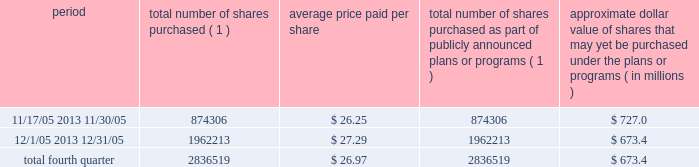Discussion and analysis of financial condition and results of operations 2014liquidity and capital resources 2014 factors affecting sources of liquidity . 201d recent sales of unregistered securities during the year ended december 31 , 2005 , we issued an aggregate of 4670335 shares of our class a common stock upon conversion of $ 57.1 million principal amount of our 3.25% ( 3.25 % ) notes .
Pursuant to the terms of the indenture , the holders of the 3.25% ( 3.25 % ) notes received 81.808 shares of class a common stock for every $ 1000 principal amount of notes converted .
The shares were issued to the noteholders in reliance on the exemption from registration set forth in section 3 ( a ) ( 9 ) of the securities act of 1933 , as amended .
No underwriters were engaged in connection with such issuances .
In connection with the conversion , we paid such holders an aggregate of $ 4.9 million , calculated based on the accrued and unpaid interest on the notes and the discounted value of the future interest payments on the notes .
Subsequent to december 31 , 2005 , we issued shares of class a common stock upon conversions of additional 3.25% ( 3.25 % ) notes , as set forth in item 9b of this annual report under the caption 201cother information . 201d during the year ended december 31 , 2005 , we issued an aggregate of 398412 shares of our class a common stock upon exercises of 55729 warrants assumed in our merger with spectrasite , inc .
In august 2005 , in connection with our merger with spectrasite , inc. , we assumed approximately 1.0 million warrants to purchase shares of spectrasite , inc .
Common stock .
Upon completion of the merger , each warrant to purchase shares of spectrasite , inc .
Common stock automatically converted into a warrant to purchase 7.15 shares of class a common stock at an exercise price of $ 32 per warrant .
Net proceeds from these warrant exercises were approximately $ 1.8 million .
The shares of class a common stock issued to the warrantholders upon exercise of the warrants were issued in reliance on the exemption from registration set forth in section 3 ( a ) ( 9 ) of the securities act of 1933 , as amended .
No underwriters were engaged in connection with such issuances .
Subsequent to december 31 , 2005 , we issued shares of class a common stock upon exercises of additional warrants , as set forth in item 9b of this annual report under the caption 201cother information . 201d issuer purchases of equity securities in november 2005 , we announced that our board of directors had approved a stock repurchase program pursuant to which we intend to repurchase up to $ 750.0 million of our class a common stock through december 2006 .
During the fourth quarter of 2005 , we repurchased 2836519 shares of our class a common stock for an aggregate of $ 76.6 million pursuant to our stock repurchase program , as follows : period total number of shares purchased ( 1 ) average price paid per share total number of shares purchased as part of publicly announced plans or programs ( 1 ) approximate dollar value of shares that may yet be purchased under the plans or programs ( in millions ) .
( 1 ) all issuer repurchases were made pursuant to the stock repurchase program publicly announced in november 2005 .
Pursuant to the program , we intend to repurchase up to $ 750.0 million of our class a common stock during the period november 2005 through december 2006 .
Under the program , our management is authorized to purchase shares from time to time in open market purchases or privately negotiated transactions at prevailing prices as permitted by securities laws and other legal requirements , and subject to market conditions and other factors .
To facilitate repurchases , we entered into a trading plan under rule 10b5-1 of the securities exchange act of 1934 , which allows us to repurchase shares during periods when we otherwise might be prevented from doing so under insider trading laws or because of self- imposed trading blackout periods .
The program may be discontinued at any time .
Since december 31 , 2005 , we have continued to repurchase shares of our class a common stock pursuant to our stock repurchase program .
Between january 1 , 2006 and march 9 , 2006 , we repurchased 3.9 million shares of class a common stock for an aggregate of $ 117.4 million pursuant to the stock repurchase program. .
During the period 11/17/05 2013 11/30/05 what was the percentage of the treasury stock purchased in the fourth quarter of 2005? 
Computations: (874306 / 2836519)
Answer: 0.30823. 